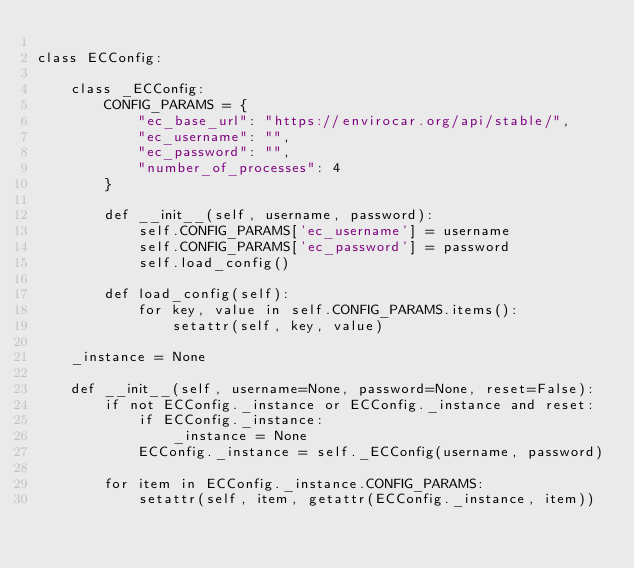<code> <loc_0><loc_0><loc_500><loc_500><_Python_>
class ECConfig:

    class _ECConfig:
        CONFIG_PARAMS = {
            "ec_base_url": "https://envirocar.org/api/stable/",
            "ec_username": "",
            "ec_password": "",
            "number_of_processes": 4
        }

        def __init__(self, username, password):
            self.CONFIG_PARAMS['ec_username'] = username
            self.CONFIG_PARAMS['ec_password'] = password
            self.load_config()

        def load_config(self):
            for key, value in self.CONFIG_PARAMS.items():
                setattr(self, key, value)

    _instance = None

    def __init__(self, username=None, password=None, reset=False):
        if not ECConfig._instance or ECConfig._instance and reset:
            if ECConfig._instance:
                _instance = None
            ECConfig._instance = self._ECConfig(username, password)

        for item in ECConfig._instance.CONFIG_PARAMS:
            setattr(self, item, getattr(ECConfig._instance, item))
</code> 